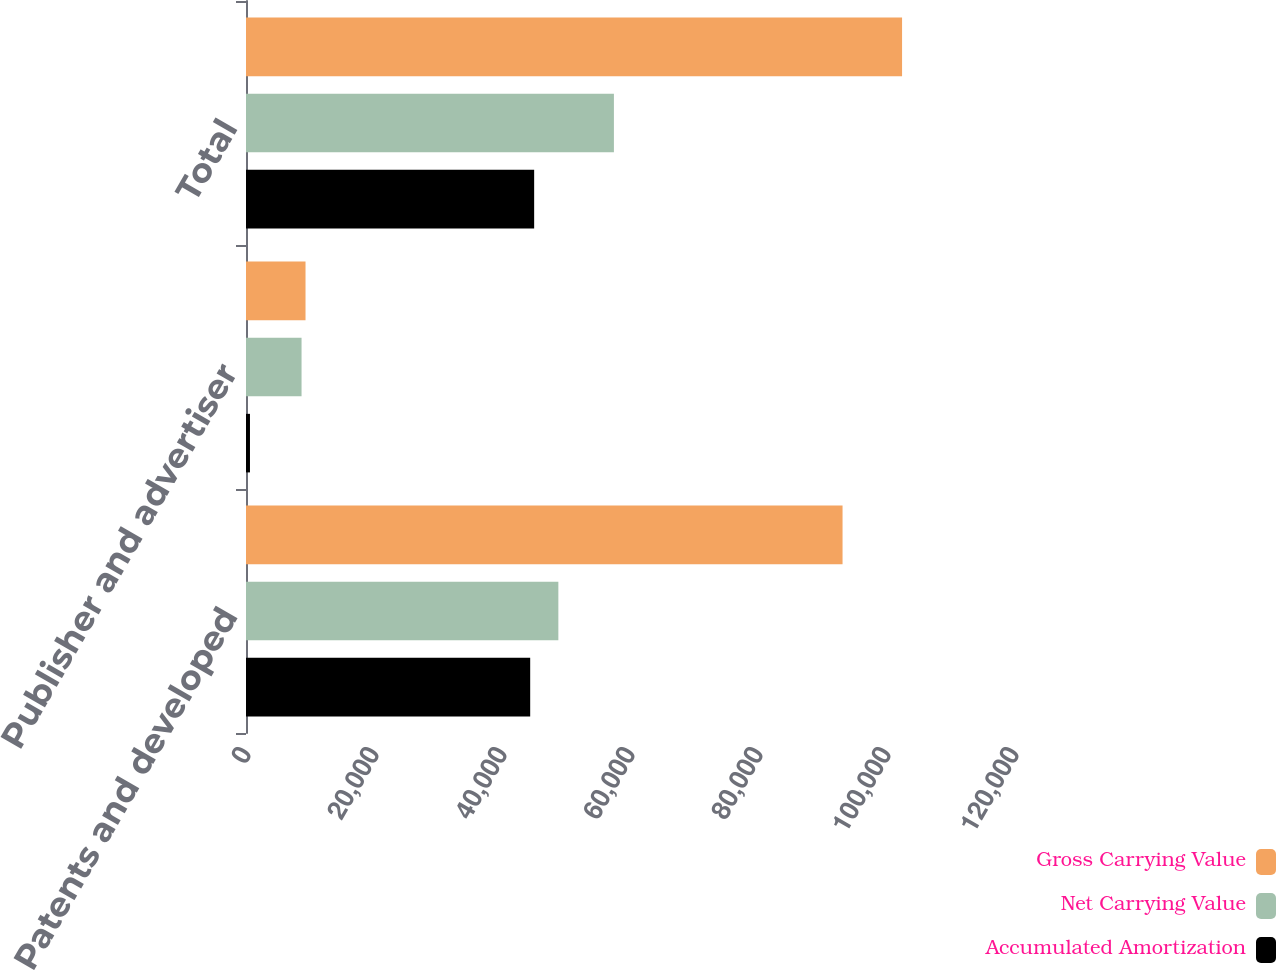<chart> <loc_0><loc_0><loc_500><loc_500><stacked_bar_chart><ecel><fcel>Patents and developed<fcel>Publisher and advertiser<fcel>Total<nl><fcel>Gross Carrying Value<fcel>93211<fcel>9300<fcel>102511<nl><fcel>Net Carrying Value<fcel>48806<fcel>8680<fcel>57486<nl><fcel>Accumulated Amortization<fcel>44405<fcel>620<fcel>45025<nl></chart> 